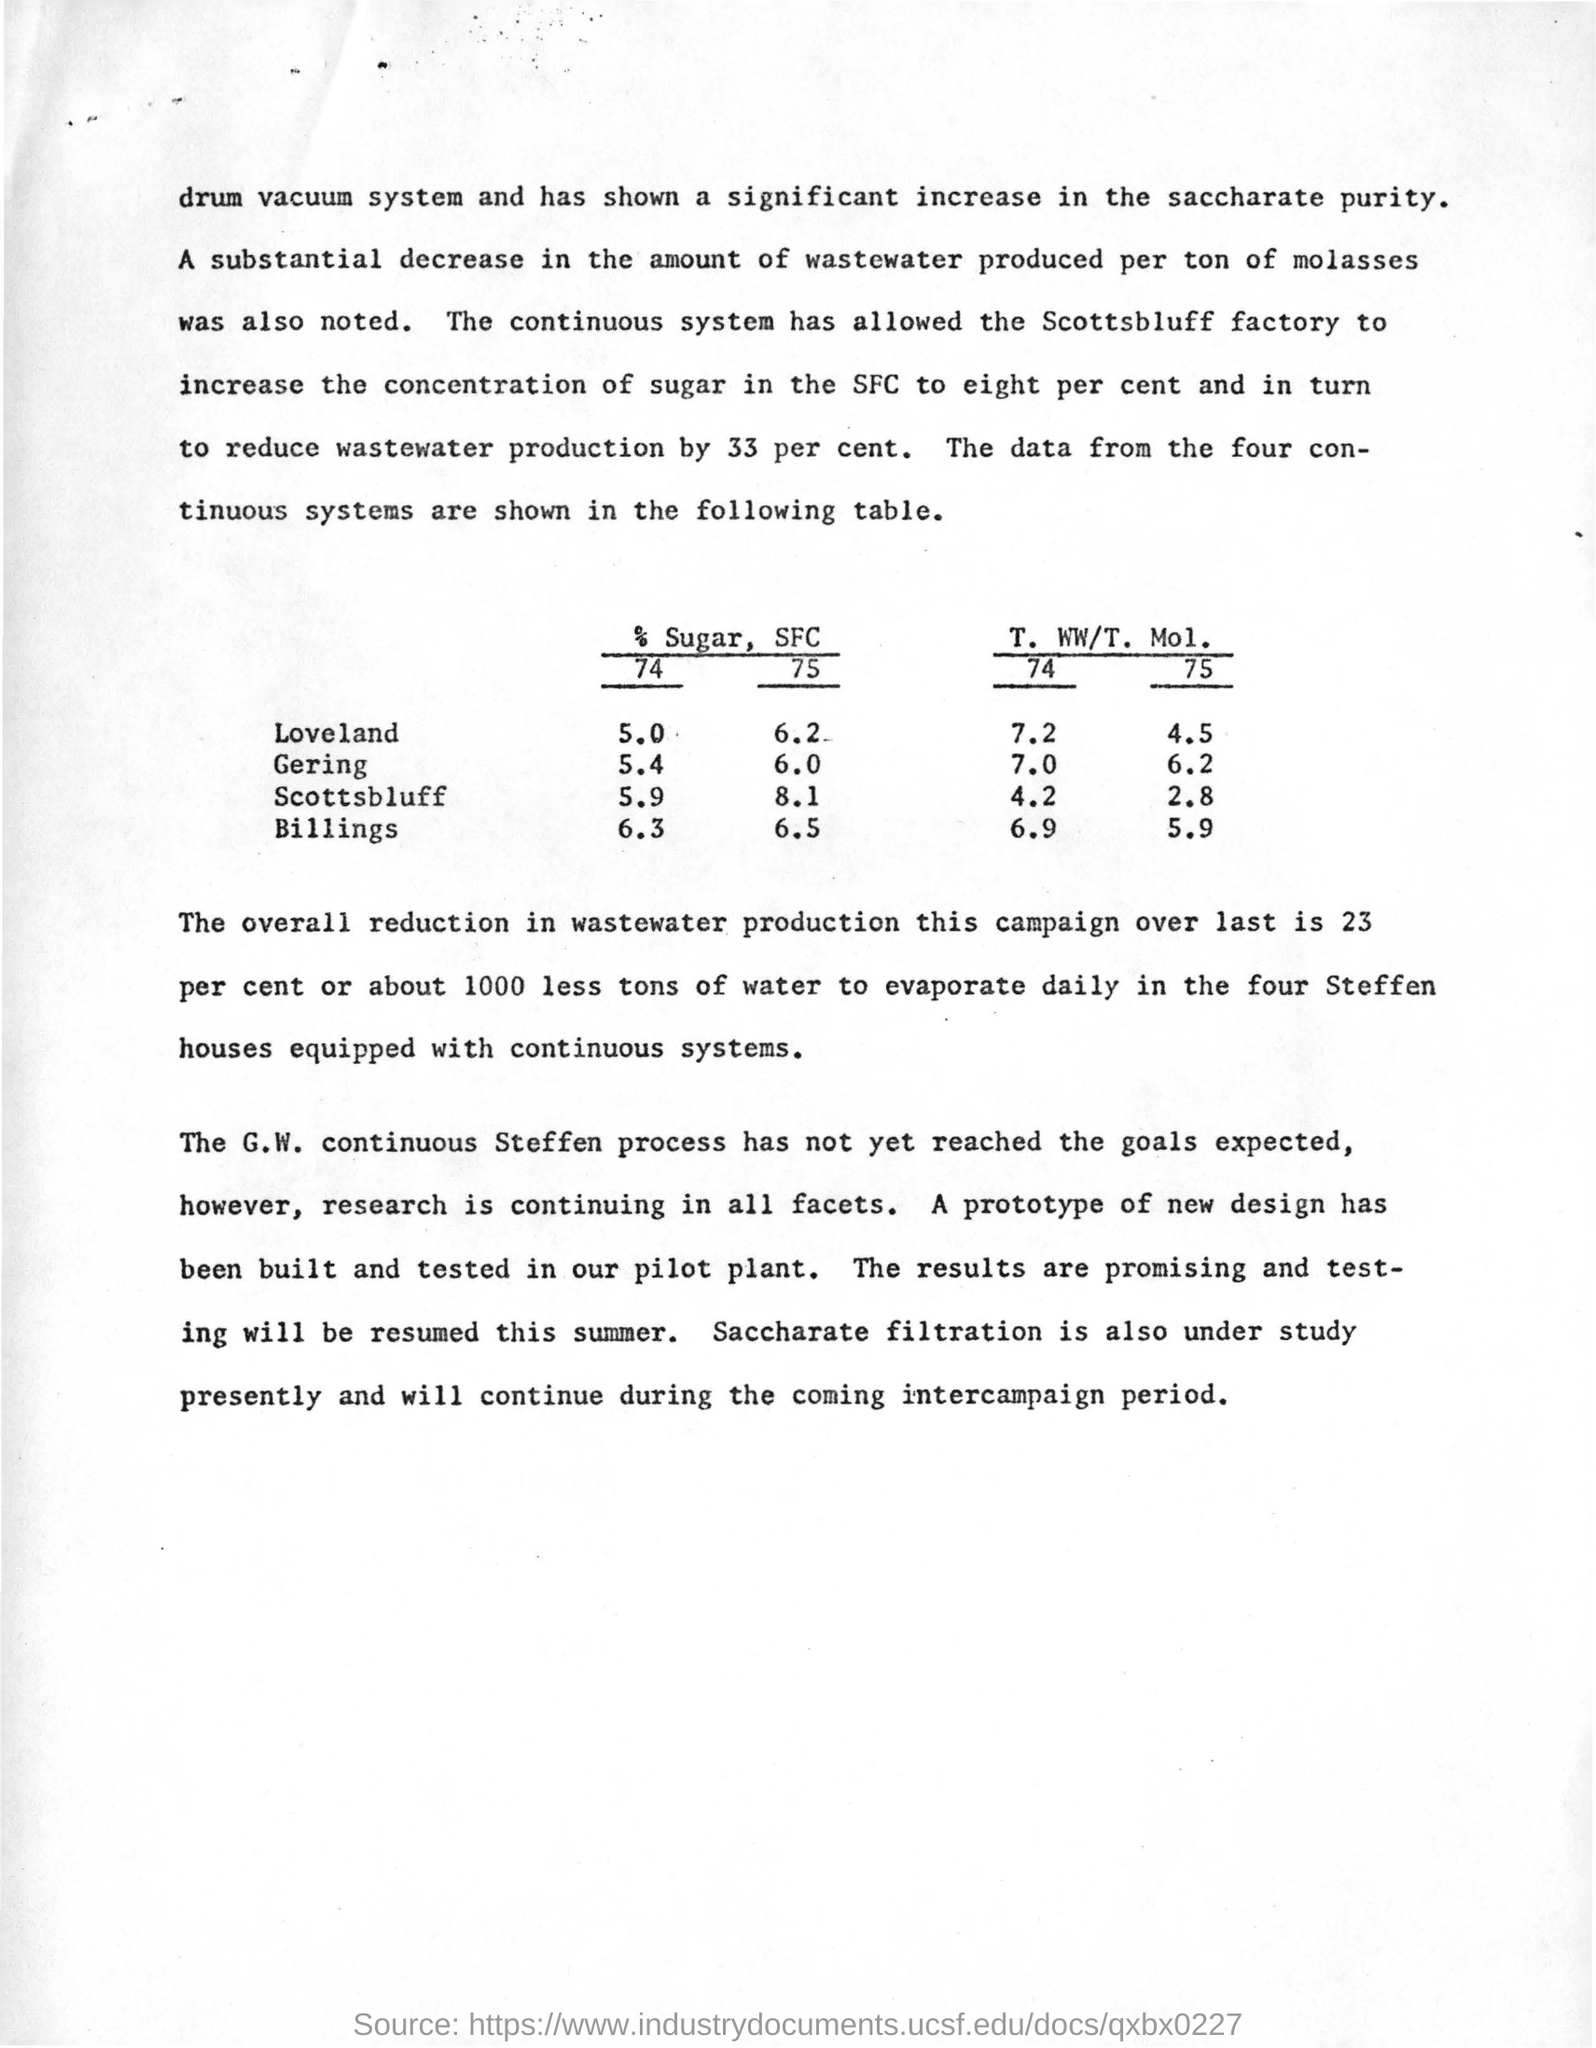Indicate a few pertinent items in this graphic. The G.W continuous steffen process has not yet reached the expected goals. The testing of the new design will be resumed this summer. Saccharate filtration is currently the subject of ongoing study. The drum vacuum system has demonstrated a significant increase in the purity of saccharate, as compared to the other systems tested. The table shows data from four continuous systems. 